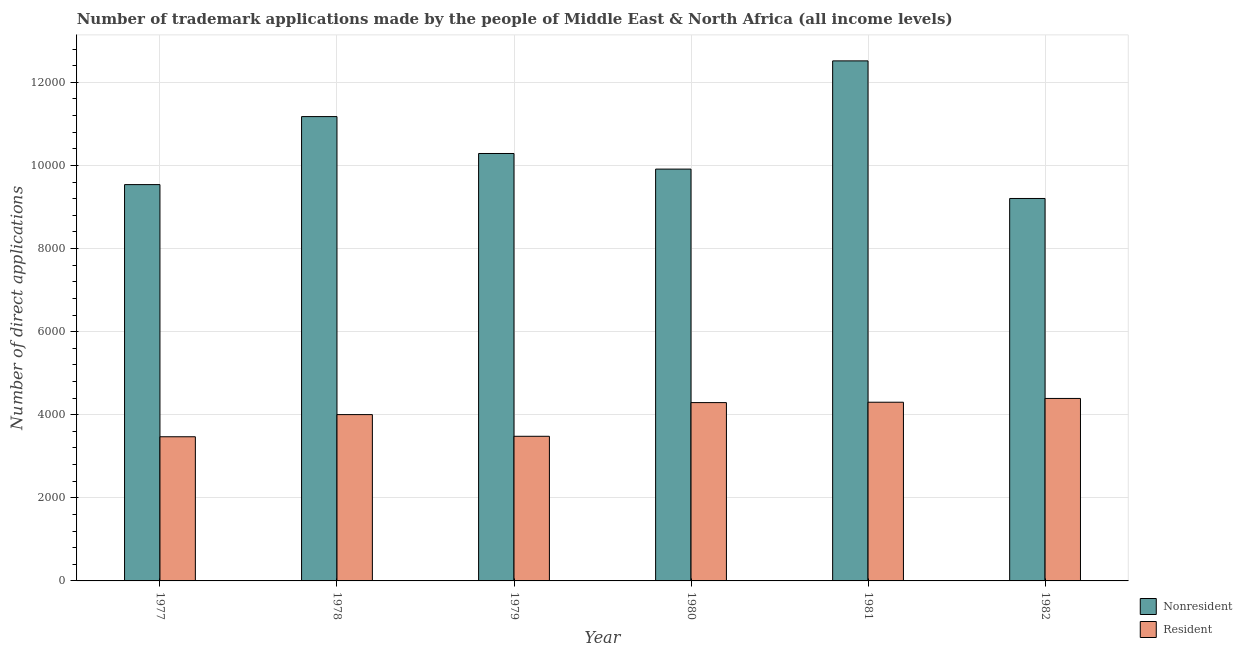How many groups of bars are there?
Give a very brief answer. 6. Are the number of bars on each tick of the X-axis equal?
Give a very brief answer. Yes. How many bars are there on the 5th tick from the right?
Ensure brevity in your answer.  2. What is the label of the 5th group of bars from the left?
Your answer should be very brief. 1981. In how many cases, is the number of bars for a given year not equal to the number of legend labels?
Give a very brief answer. 0. What is the number of trademark applications made by residents in 1981?
Give a very brief answer. 4301. Across all years, what is the maximum number of trademark applications made by residents?
Make the answer very short. 4392. Across all years, what is the minimum number of trademark applications made by residents?
Provide a succinct answer. 3470. In which year was the number of trademark applications made by non residents maximum?
Offer a very short reply. 1981. What is the total number of trademark applications made by non residents in the graph?
Your response must be concise. 6.26e+04. What is the difference between the number of trademark applications made by non residents in 1981 and that in 1982?
Your answer should be compact. 3312. What is the difference between the number of trademark applications made by non residents in 1979 and the number of trademark applications made by residents in 1980?
Provide a succinct answer. 376. What is the average number of trademark applications made by non residents per year?
Your response must be concise. 1.04e+04. What is the ratio of the number of trademark applications made by non residents in 1981 to that in 1982?
Your answer should be very brief. 1.36. Is the difference between the number of trademark applications made by residents in 1979 and 1982 greater than the difference between the number of trademark applications made by non residents in 1979 and 1982?
Make the answer very short. No. What is the difference between the highest and the second highest number of trademark applications made by non residents?
Offer a very short reply. 1341. What is the difference between the highest and the lowest number of trademark applications made by non residents?
Your response must be concise. 3312. In how many years, is the number of trademark applications made by residents greater than the average number of trademark applications made by residents taken over all years?
Offer a very short reply. 4. What does the 1st bar from the left in 1977 represents?
Give a very brief answer. Nonresident. What does the 2nd bar from the right in 1982 represents?
Keep it short and to the point. Nonresident. Does the graph contain any zero values?
Your answer should be very brief. No. Does the graph contain grids?
Keep it short and to the point. Yes. How many legend labels are there?
Keep it short and to the point. 2. What is the title of the graph?
Provide a succinct answer. Number of trademark applications made by the people of Middle East & North Africa (all income levels). Does "All education staff compensation" appear as one of the legend labels in the graph?
Make the answer very short. No. What is the label or title of the Y-axis?
Provide a succinct answer. Number of direct applications. What is the Number of direct applications in Nonresident in 1977?
Offer a terse response. 9539. What is the Number of direct applications in Resident in 1977?
Your response must be concise. 3470. What is the Number of direct applications of Nonresident in 1978?
Give a very brief answer. 1.12e+04. What is the Number of direct applications of Resident in 1978?
Provide a short and direct response. 4003. What is the Number of direct applications in Nonresident in 1979?
Provide a succinct answer. 1.03e+04. What is the Number of direct applications in Resident in 1979?
Provide a short and direct response. 3481. What is the Number of direct applications in Nonresident in 1980?
Ensure brevity in your answer.  9912. What is the Number of direct applications of Resident in 1980?
Provide a succinct answer. 4292. What is the Number of direct applications of Nonresident in 1981?
Your answer should be compact. 1.25e+04. What is the Number of direct applications in Resident in 1981?
Provide a succinct answer. 4301. What is the Number of direct applications of Nonresident in 1982?
Give a very brief answer. 9205. What is the Number of direct applications of Resident in 1982?
Make the answer very short. 4392. Across all years, what is the maximum Number of direct applications in Nonresident?
Offer a very short reply. 1.25e+04. Across all years, what is the maximum Number of direct applications in Resident?
Provide a short and direct response. 4392. Across all years, what is the minimum Number of direct applications in Nonresident?
Give a very brief answer. 9205. Across all years, what is the minimum Number of direct applications in Resident?
Provide a short and direct response. 3470. What is the total Number of direct applications in Nonresident in the graph?
Offer a very short reply. 6.26e+04. What is the total Number of direct applications in Resident in the graph?
Make the answer very short. 2.39e+04. What is the difference between the Number of direct applications of Nonresident in 1977 and that in 1978?
Your answer should be very brief. -1637. What is the difference between the Number of direct applications in Resident in 1977 and that in 1978?
Keep it short and to the point. -533. What is the difference between the Number of direct applications in Nonresident in 1977 and that in 1979?
Give a very brief answer. -749. What is the difference between the Number of direct applications in Resident in 1977 and that in 1979?
Your answer should be very brief. -11. What is the difference between the Number of direct applications in Nonresident in 1977 and that in 1980?
Offer a very short reply. -373. What is the difference between the Number of direct applications in Resident in 1977 and that in 1980?
Provide a succinct answer. -822. What is the difference between the Number of direct applications in Nonresident in 1977 and that in 1981?
Your response must be concise. -2978. What is the difference between the Number of direct applications of Resident in 1977 and that in 1981?
Offer a very short reply. -831. What is the difference between the Number of direct applications of Nonresident in 1977 and that in 1982?
Give a very brief answer. 334. What is the difference between the Number of direct applications in Resident in 1977 and that in 1982?
Give a very brief answer. -922. What is the difference between the Number of direct applications of Nonresident in 1978 and that in 1979?
Provide a short and direct response. 888. What is the difference between the Number of direct applications of Resident in 1978 and that in 1979?
Offer a terse response. 522. What is the difference between the Number of direct applications in Nonresident in 1978 and that in 1980?
Your answer should be compact. 1264. What is the difference between the Number of direct applications in Resident in 1978 and that in 1980?
Provide a short and direct response. -289. What is the difference between the Number of direct applications of Nonresident in 1978 and that in 1981?
Your response must be concise. -1341. What is the difference between the Number of direct applications of Resident in 1978 and that in 1981?
Give a very brief answer. -298. What is the difference between the Number of direct applications in Nonresident in 1978 and that in 1982?
Your answer should be compact. 1971. What is the difference between the Number of direct applications of Resident in 1978 and that in 1982?
Ensure brevity in your answer.  -389. What is the difference between the Number of direct applications of Nonresident in 1979 and that in 1980?
Give a very brief answer. 376. What is the difference between the Number of direct applications in Resident in 1979 and that in 1980?
Ensure brevity in your answer.  -811. What is the difference between the Number of direct applications in Nonresident in 1979 and that in 1981?
Provide a succinct answer. -2229. What is the difference between the Number of direct applications in Resident in 1979 and that in 1981?
Offer a terse response. -820. What is the difference between the Number of direct applications of Nonresident in 1979 and that in 1982?
Ensure brevity in your answer.  1083. What is the difference between the Number of direct applications in Resident in 1979 and that in 1982?
Offer a very short reply. -911. What is the difference between the Number of direct applications in Nonresident in 1980 and that in 1981?
Offer a very short reply. -2605. What is the difference between the Number of direct applications of Nonresident in 1980 and that in 1982?
Your answer should be compact. 707. What is the difference between the Number of direct applications in Resident in 1980 and that in 1982?
Ensure brevity in your answer.  -100. What is the difference between the Number of direct applications in Nonresident in 1981 and that in 1982?
Your answer should be compact. 3312. What is the difference between the Number of direct applications in Resident in 1981 and that in 1982?
Offer a terse response. -91. What is the difference between the Number of direct applications in Nonresident in 1977 and the Number of direct applications in Resident in 1978?
Offer a terse response. 5536. What is the difference between the Number of direct applications in Nonresident in 1977 and the Number of direct applications in Resident in 1979?
Your answer should be compact. 6058. What is the difference between the Number of direct applications of Nonresident in 1977 and the Number of direct applications of Resident in 1980?
Offer a very short reply. 5247. What is the difference between the Number of direct applications in Nonresident in 1977 and the Number of direct applications in Resident in 1981?
Make the answer very short. 5238. What is the difference between the Number of direct applications in Nonresident in 1977 and the Number of direct applications in Resident in 1982?
Your response must be concise. 5147. What is the difference between the Number of direct applications in Nonresident in 1978 and the Number of direct applications in Resident in 1979?
Your answer should be compact. 7695. What is the difference between the Number of direct applications in Nonresident in 1978 and the Number of direct applications in Resident in 1980?
Your answer should be very brief. 6884. What is the difference between the Number of direct applications of Nonresident in 1978 and the Number of direct applications of Resident in 1981?
Offer a terse response. 6875. What is the difference between the Number of direct applications of Nonresident in 1978 and the Number of direct applications of Resident in 1982?
Make the answer very short. 6784. What is the difference between the Number of direct applications of Nonresident in 1979 and the Number of direct applications of Resident in 1980?
Offer a terse response. 5996. What is the difference between the Number of direct applications of Nonresident in 1979 and the Number of direct applications of Resident in 1981?
Your answer should be very brief. 5987. What is the difference between the Number of direct applications in Nonresident in 1979 and the Number of direct applications in Resident in 1982?
Your response must be concise. 5896. What is the difference between the Number of direct applications in Nonresident in 1980 and the Number of direct applications in Resident in 1981?
Your response must be concise. 5611. What is the difference between the Number of direct applications of Nonresident in 1980 and the Number of direct applications of Resident in 1982?
Keep it short and to the point. 5520. What is the difference between the Number of direct applications in Nonresident in 1981 and the Number of direct applications in Resident in 1982?
Provide a short and direct response. 8125. What is the average Number of direct applications in Nonresident per year?
Provide a short and direct response. 1.04e+04. What is the average Number of direct applications of Resident per year?
Your response must be concise. 3989.83. In the year 1977, what is the difference between the Number of direct applications of Nonresident and Number of direct applications of Resident?
Offer a very short reply. 6069. In the year 1978, what is the difference between the Number of direct applications of Nonresident and Number of direct applications of Resident?
Provide a succinct answer. 7173. In the year 1979, what is the difference between the Number of direct applications in Nonresident and Number of direct applications in Resident?
Your answer should be compact. 6807. In the year 1980, what is the difference between the Number of direct applications in Nonresident and Number of direct applications in Resident?
Your answer should be compact. 5620. In the year 1981, what is the difference between the Number of direct applications of Nonresident and Number of direct applications of Resident?
Your answer should be very brief. 8216. In the year 1982, what is the difference between the Number of direct applications of Nonresident and Number of direct applications of Resident?
Make the answer very short. 4813. What is the ratio of the Number of direct applications in Nonresident in 1977 to that in 1978?
Your response must be concise. 0.85. What is the ratio of the Number of direct applications of Resident in 1977 to that in 1978?
Make the answer very short. 0.87. What is the ratio of the Number of direct applications in Nonresident in 1977 to that in 1979?
Your answer should be very brief. 0.93. What is the ratio of the Number of direct applications in Nonresident in 1977 to that in 1980?
Offer a terse response. 0.96. What is the ratio of the Number of direct applications in Resident in 1977 to that in 1980?
Provide a short and direct response. 0.81. What is the ratio of the Number of direct applications in Nonresident in 1977 to that in 1981?
Give a very brief answer. 0.76. What is the ratio of the Number of direct applications of Resident in 1977 to that in 1981?
Give a very brief answer. 0.81. What is the ratio of the Number of direct applications in Nonresident in 1977 to that in 1982?
Ensure brevity in your answer.  1.04. What is the ratio of the Number of direct applications of Resident in 1977 to that in 1982?
Make the answer very short. 0.79. What is the ratio of the Number of direct applications in Nonresident in 1978 to that in 1979?
Keep it short and to the point. 1.09. What is the ratio of the Number of direct applications in Resident in 1978 to that in 1979?
Provide a short and direct response. 1.15. What is the ratio of the Number of direct applications of Nonresident in 1978 to that in 1980?
Ensure brevity in your answer.  1.13. What is the ratio of the Number of direct applications in Resident in 1978 to that in 1980?
Your response must be concise. 0.93. What is the ratio of the Number of direct applications in Nonresident in 1978 to that in 1981?
Provide a short and direct response. 0.89. What is the ratio of the Number of direct applications of Resident in 1978 to that in 1981?
Your response must be concise. 0.93. What is the ratio of the Number of direct applications of Nonresident in 1978 to that in 1982?
Your answer should be very brief. 1.21. What is the ratio of the Number of direct applications in Resident in 1978 to that in 1982?
Your answer should be very brief. 0.91. What is the ratio of the Number of direct applications of Nonresident in 1979 to that in 1980?
Make the answer very short. 1.04. What is the ratio of the Number of direct applications of Resident in 1979 to that in 1980?
Give a very brief answer. 0.81. What is the ratio of the Number of direct applications of Nonresident in 1979 to that in 1981?
Your answer should be very brief. 0.82. What is the ratio of the Number of direct applications of Resident in 1979 to that in 1981?
Give a very brief answer. 0.81. What is the ratio of the Number of direct applications of Nonresident in 1979 to that in 1982?
Offer a very short reply. 1.12. What is the ratio of the Number of direct applications of Resident in 1979 to that in 1982?
Make the answer very short. 0.79. What is the ratio of the Number of direct applications of Nonresident in 1980 to that in 1981?
Offer a terse response. 0.79. What is the ratio of the Number of direct applications of Resident in 1980 to that in 1981?
Give a very brief answer. 1. What is the ratio of the Number of direct applications in Nonresident in 1980 to that in 1982?
Your response must be concise. 1.08. What is the ratio of the Number of direct applications of Resident in 1980 to that in 1982?
Provide a succinct answer. 0.98. What is the ratio of the Number of direct applications of Nonresident in 1981 to that in 1982?
Give a very brief answer. 1.36. What is the ratio of the Number of direct applications in Resident in 1981 to that in 1982?
Provide a succinct answer. 0.98. What is the difference between the highest and the second highest Number of direct applications in Nonresident?
Offer a very short reply. 1341. What is the difference between the highest and the second highest Number of direct applications in Resident?
Offer a very short reply. 91. What is the difference between the highest and the lowest Number of direct applications of Nonresident?
Make the answer very short. 3312. What is the difference between the highest and the lowest Number of direct applications of Resident?
Ensure brevity in your answer.  922. 